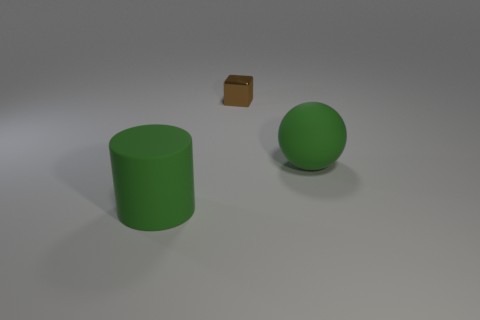How would you describe the overall setting in which these objects are placed? The objects are positioned in a sparse, simple 3D-rendered scene with a neutral, non-textured surface, and a relatively plain background that offers no additional context, suggesting a focus purely on the objects themselves for illustrative purposes. 